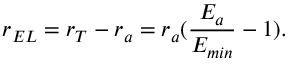Convert formula to latex. <formula><loc_0><loc_0><loc_500><loc_500>r _ { E L } = r _ { T } - r _ { a } = r _ { a } ( \frac { E _ { a } } { E _ { \min } } - 1 ) .</formula> 